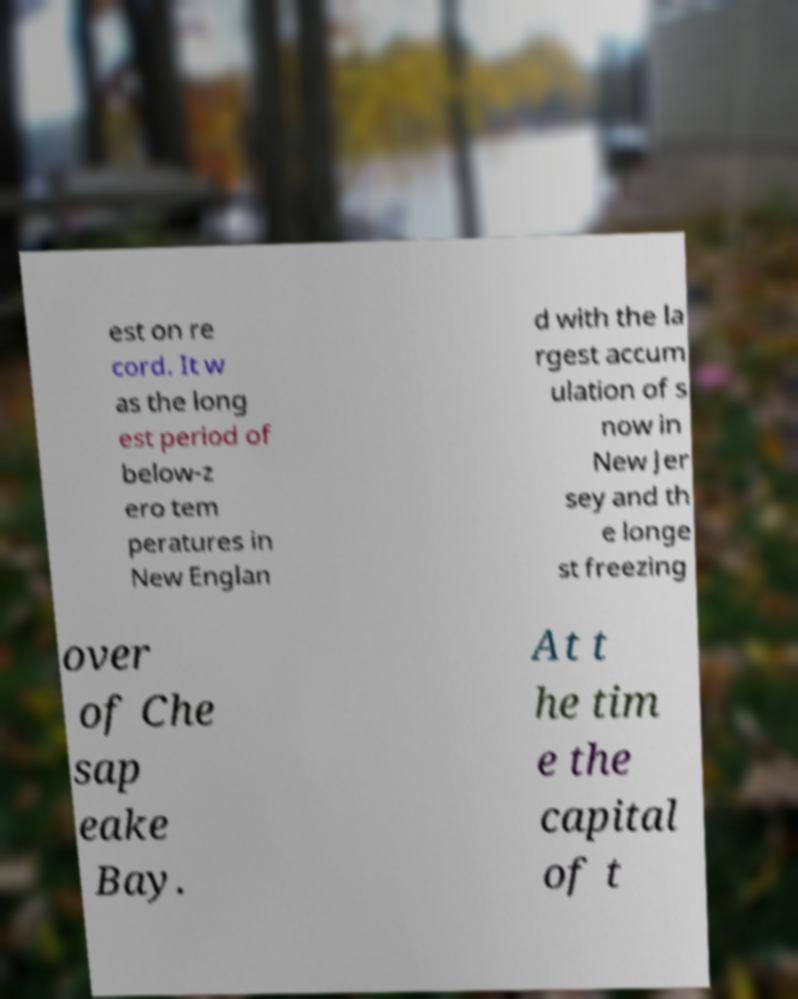There's text embedded in this image that I need extracted. Can you transcribe it verbatim? est on re cord. It w as the long est period of below-z ero tem peratures in New Englan d with the la rgest accum ulation of s now in New Jer sey and th e longe st freezing over of Che sap eake Bay. At t he tim e the capital of t 